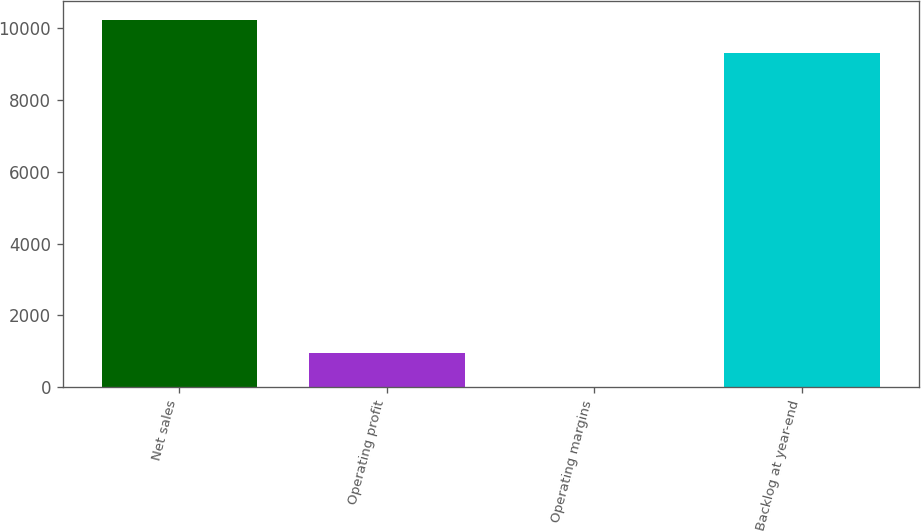Convert chart. <chart><loc_0><loc_0><loc_500><loc_500><bar_chart><fcel>Net sales<fcel>Operating profit<fcel>Operating margins<fcel>Backlog at year-end<nl><fcel>10237.2<fcel>946.47<fcel>9.3<fcel>9300<nl></chart> 